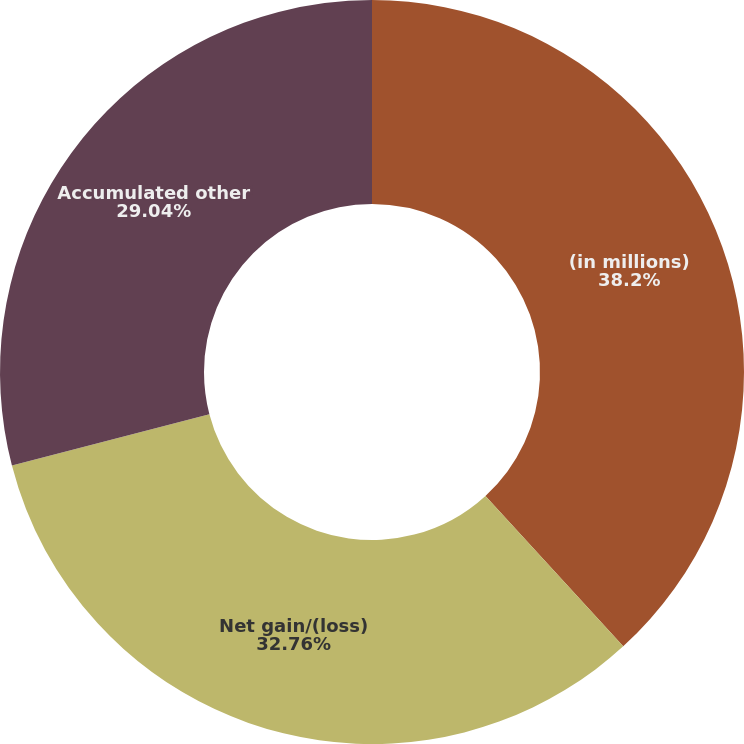<chart> <loc_0><loc_0><loc_500><loc_500><pie_chart><fcel>(in millions)<fcel>Net gain/(loss)<fcel>Accumulated other<nl><fcel>38.2%<fcel>32.76%<fcel>29.04%<nl></chart> 